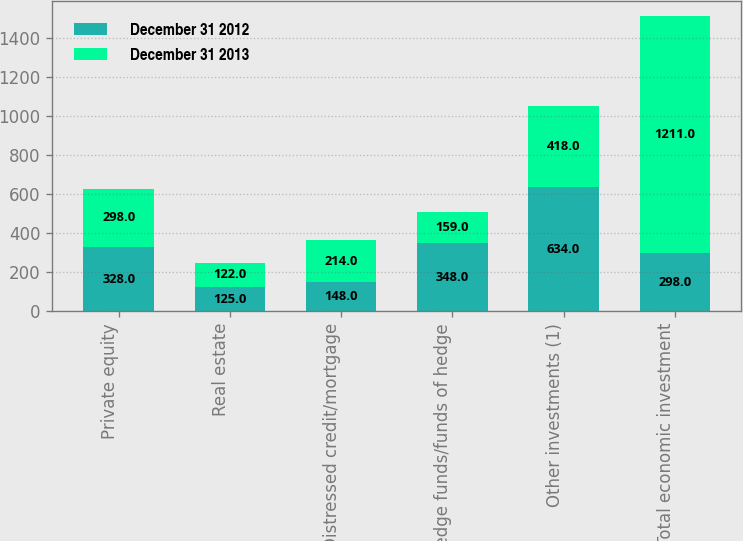Convert chart to OTSL. <chart><loc_0><loc_0><loc_500><loc_500><stacked_bar_chart><ecel><fcel>Private equity<fcel>Real estate<fcel>Distressed credit/mortgage<fcel>Hedge funds/funds of hedge<fcel>Other investments (1)<fcel>Total economic investment<nl><fcel>December 31 2012<fcel>328<fcel>125<fcel>148<fcel>348<fcel>634<fcel>298<nl><fcel>December 31 2013<fcel>298<fcel>122<fcel>214<fcel>159<fcel>418<fcel>1211<nl></chart> 